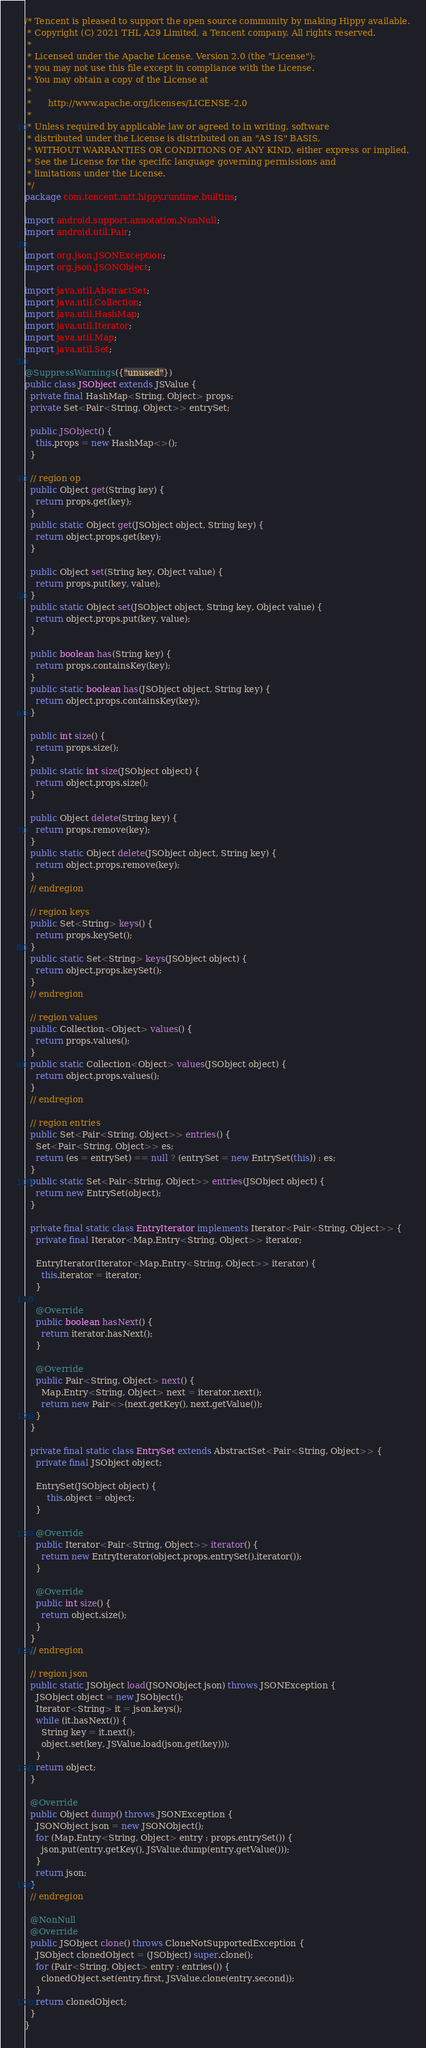Convert code to text. <code><loc_0><loc_0><loc_500><loc_500><_Java_>/* Tencent is pleased to support the open source community by making Hippy available.
 * Copyright (C) 2021 THL A29 Limited, a Tencent company. All rights reserved.
 *
 * Licensed under the Apache License, Version 2.0 (the "License");
 * you may not use this file except in compliance with the License.
 * You may obtain a copy of the License at
 *
 *      http://www.apache.org/licenses/LICENSE-2.0
 *
 * Unless required by applicable law or agreed to in writing, software
 * distributed under the License is distributed on an "AS IS" BASIS,
 * WITHOUT WARRANTIES OR CONDITIONS OF ANY KIND, either express or implied.
 * See the License for the specific language governing permissions and
 * limitations under the License.
 */
package com.tencent.mtt.hippy.runtime.builtins;

import android.support.annotation.NonNull;
import android.util.Pair;

import org.json.JSONException;
import org.json.JSONObject;

import java.util.AbstractSet;
import java.util.Collection;
import java.util.HashMap;
import java.util.Iterator;
import java.util.Map;
import java.util.Set;

@SuppressWarnings({"unused"})
public class JSObject extends JSValue {
  private final HashMap<String, Object> props;
  private Set<Pair<String, Object>> entrySet;

  public JSObject() {
    this.props = new HashMap<>();
  }

  // region op
  public Object get(String key) {
    return props.get(key);
  }
  public static Object get(JSObject object, String key) {
    return object.props.get(key);
  }

  public Object set(String key, Object value) {
    return props.put(key, value);
  }
  public static Object set(JSObject object, String key, Object value) {
    return object.props.put(key, value);
  }

  public boolean has(String key) {
    return props.containsKey(key);
  }
  public static boolean has(JSObject object, String key) {
    return object.props.containsKey(key);
  }

  public int size() {
    return props.size();
  }
  public static int size(JSObject object) {
    return object.props.size();
  }

  public Object delete(String key) {
    return props.remove(key);
  }
  public static Object delete(JSObject object, String key) {
    return object.props.remove(key);
  }
  // endregion

  // region keys
  public Set<String> keys() {
    return props.keySet();
  }
  public static Set<String> keys(JSObject object) {
    return object.props.keySet();
  }
  // endregion

  // region values
  public Collection<Object> values() {
    return props.values();
  }
  public static Collection<Object> values(JSObject object) {
    return object.props.values();
  }
  // endregion

  // region entries
  public Set<Pair<String, Object>> entries() {
    Set<Pair<String, Object>> es;
    return (es = entrySet) == null ? (entrySet = new EntrySet(this)) : es;
  }
  public static Set<Pair<String, Object>> entries(JSObject object) {
    return new EntrySet(object);
  }

  private final static class EntryIterator implements Iterator<Pair<String, Object>> {
    private final Iterator<Map.Entry<String, Object>> iterator;

    EntryIterator(Iterator<Map.Entry<String, Object>> iterator) {
      this.iterator = iterator;
    }

    @Override
    public boolean hasNext() {
      return iterator.hasNext();
    }

    @Override
    public Pair<String, Object> next() {
      Map.Entry<String, Object> next = iterator.next();
      return new Pair<>(next.getKey(), next.getValue());
    }
  }

  private final static class EntrySet extends AbstractSet<Pair<String, Object>> {
    private final JSObject object;

    EntrySet(JSObject object) {
        this.object = object;
    }

    @Override
    public Iterator<Pair<String, Object>> iterator() {
      return new EntryIterator(object.props.entrySet().iterator());
    }

    @Override
    public int size() {
      return object.size();
    }
  }
  // endregion

  // region json
  public static JSObject load(JSONObject json) throws JSONException {
    JSObject object = new JSObject();
    Iterator<String> it = json.keys();
    while (it.hasNext()) {
      String key = it.next();
      object.set(key, JSValue.load(json.get(key)));
    }
    return object;
  }

  @Override
  public Object dump() throws JSONException {
    JSONObject json = new JSONObject();
    for (Map.Entry<String, Object> entry : props.entrySet()) {
      json.put(entry.getKey(), JSValue.dump(entry.getValue()));
    }
    return json;
  }
  // endregion

  @NonNull
  @Override
  public JSObject clone() throws CloneNotSupportedException {
    JSObject clonedObject = (JSObject) super.clone();
    for (Pair<String, Object> entry : entries()) {
      clonedObject.set(entry.first, JSValue.clone(entry.second));
    }
    return clonedObject;
  }
}
</code> 